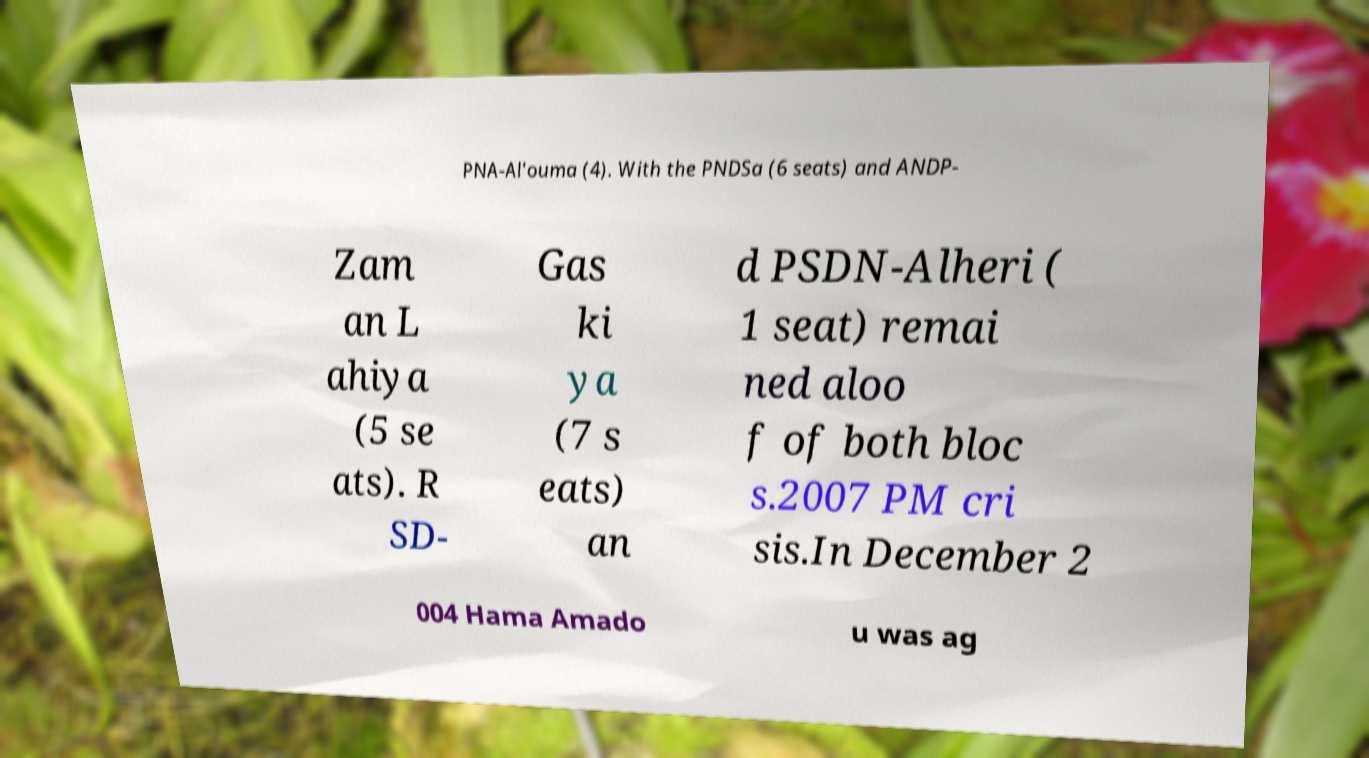For documentation purposes, I need the text within this image transcribed. Could you provide that? PNA-Al'ouma (4). With the PNDSa (6 seats) and ANDP- Zam an L ahiya (5 se ats). R SD- Gas ki ya (7 s eats) an d PSDN-Alheri ( 1 seat) remai ned aloo f of both bloc s.2007 PM cri sis.In December 2 004 Hama Amado u was ag 